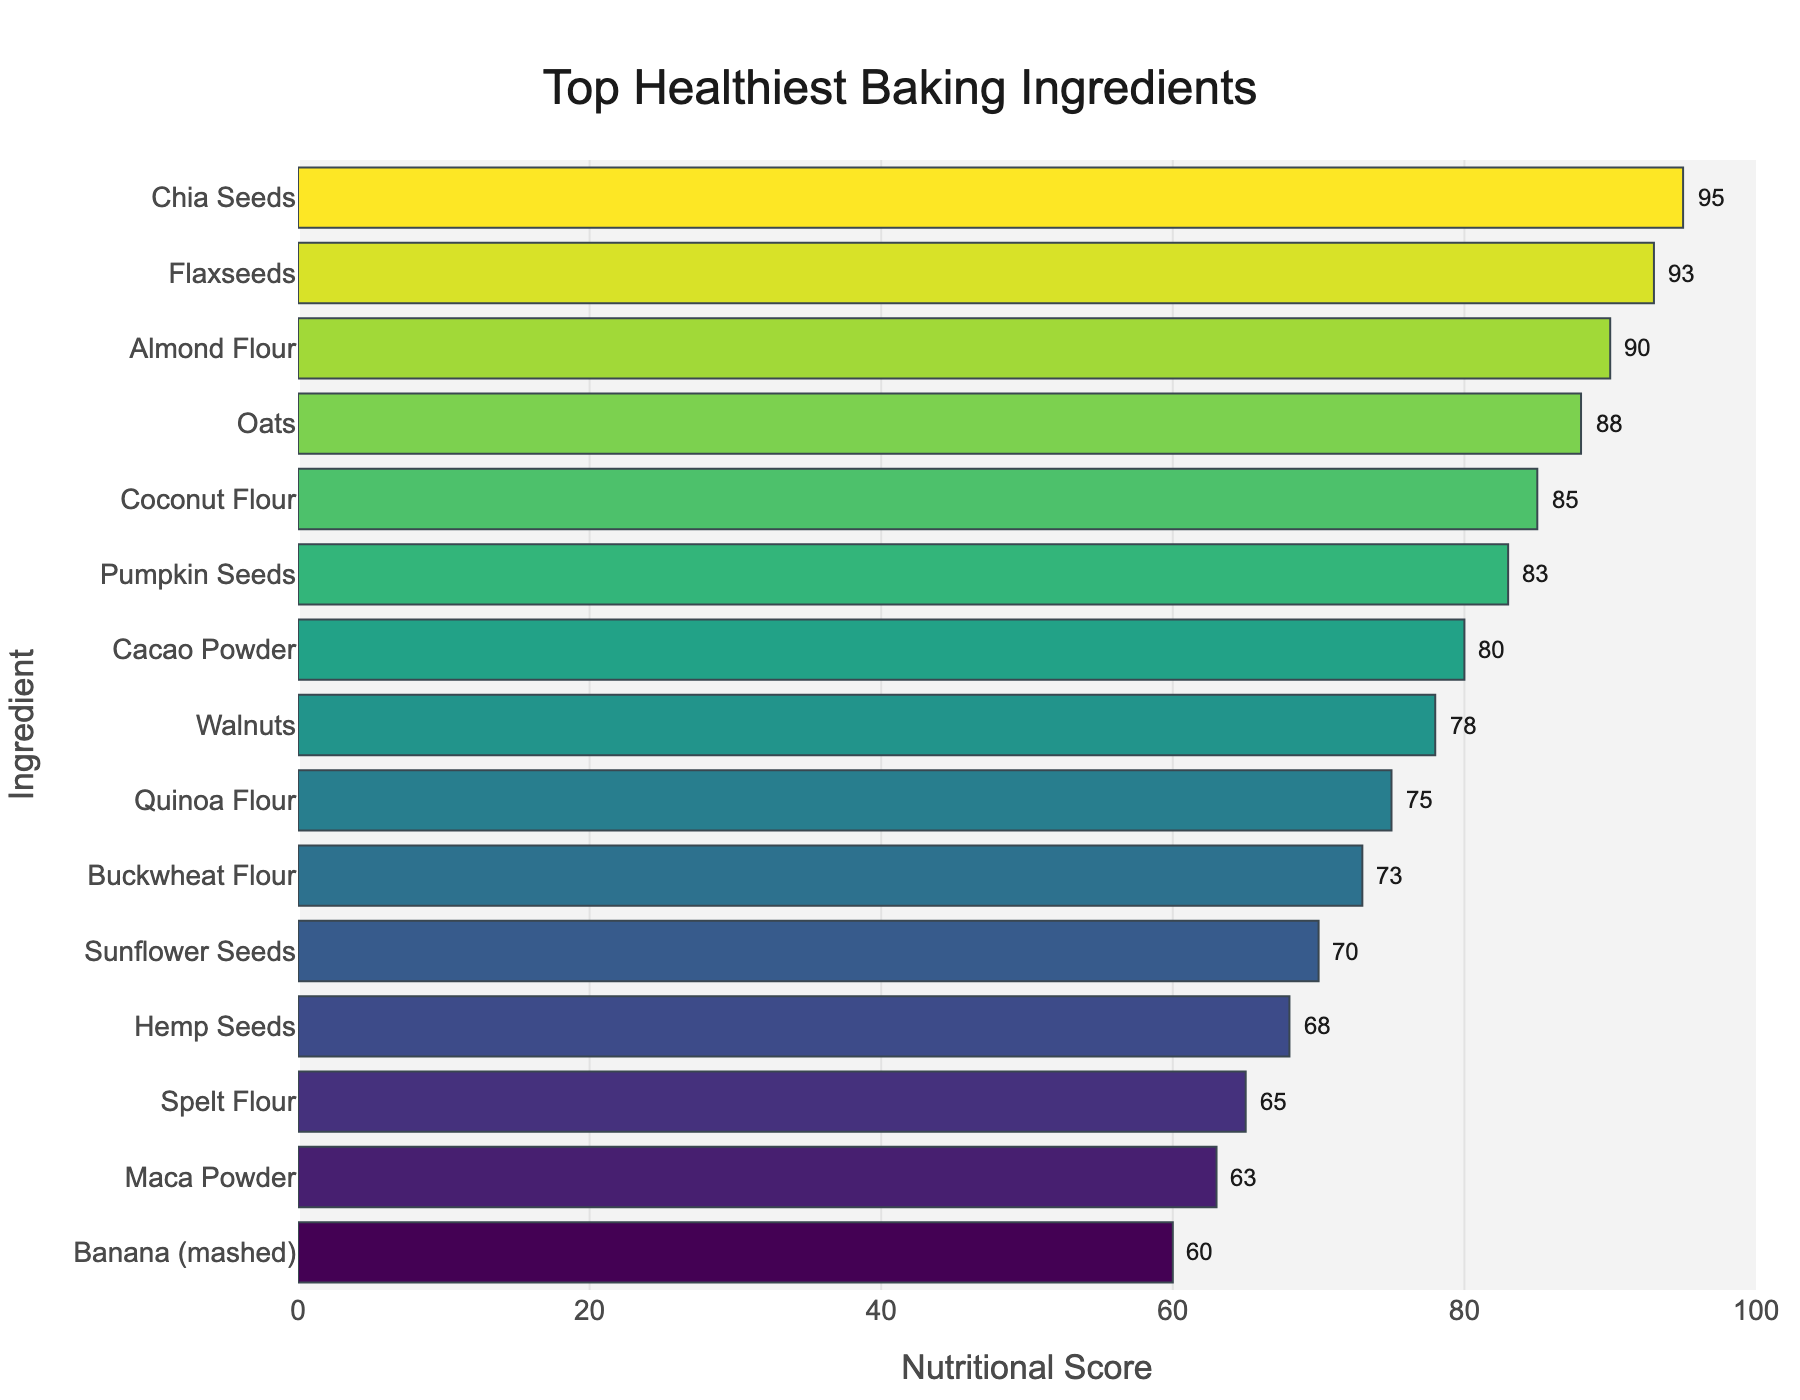Which ingredient has the highest nutritional score? Find the bar with the highest value on the graph. The bar for Chia Seeds has the highest score of 95.
Answer: Chia Seeds What is the difference in nutritional score between Flaxseeds and Buckwheat Flour? Identify the scores for Flaxseeds (93) and Buckwheat Flour (73) from the graph. Subtract the smaller score from the larger one: 93 - 73 = 20.
Answer: 20 Which ingredient is higher on the nutritional score scale, Oats or Walnuts? Compare the bars for Oats (88) and Walnuts (78). Oats have a higher nutritional score.
Answer: Oats How many ingredients have a nutritional score above 80? Count the bars on the graph with scores higher than 80: Chia Seeds (95), Flaxseeds (93), Almond Flour (90), and Oats (88) all qualify, and Pumpkin Seeds (83). There are 5 in total.
Answer: 5 What is the average nutritional score of the top three ingredients? Find the scores of the top three ingredients: Chia Seeds (95), Flaxseeds (93), and Almond Flour (90). Then, calculate the average: (95 + 93 + 90) / 3 = 92.67.
Answer: 92.67 Is the nutritional score of Quinoa Flour closer to that of Walnuts or Coconut Flour? Check the scores: Quinoa Flour (75), Walnuts (78), Coconut Flour (85). Calculate differences: 78 - 75 = 3 for Walnuts, 85 - 75 = 10 for Coconut Flour. Quinoa Flour is closer to Walnuts.
Answer: Walnuts Which ingredient is ranked fifth in nutritional score? Sort the ingredients by nutritional score, and find the fifth one in the list. It is Pumpkin Seeds with a score of 83.
Answer: Pumpkin Seeds 